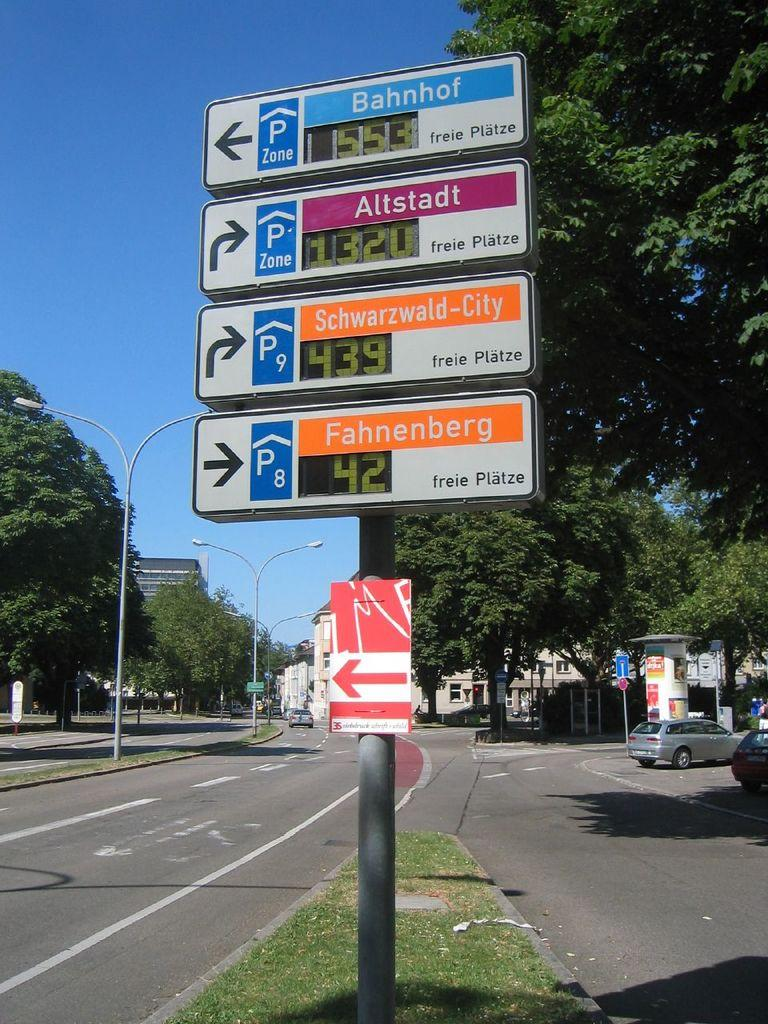<image>
Relay a brief, clear account of the picture shown. A series of signs directing motorists on of which says Bahnhof. 